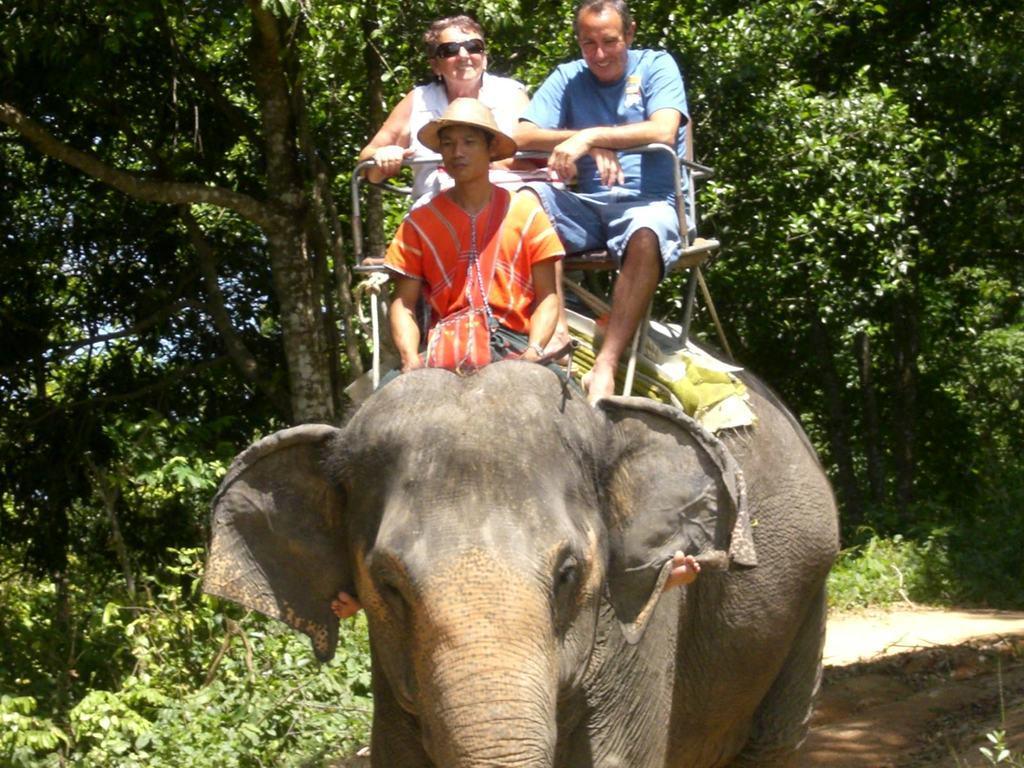Could you give a brief overview of what you see in this image? The picture is taken at the outdoor where an elephant is present and on the elephant there are three people sitting, one person is wearing orange dress with a hat and another man is wearing a blue dress and one woman is wearing white dress and sun glasses too, behind them there are trees. 